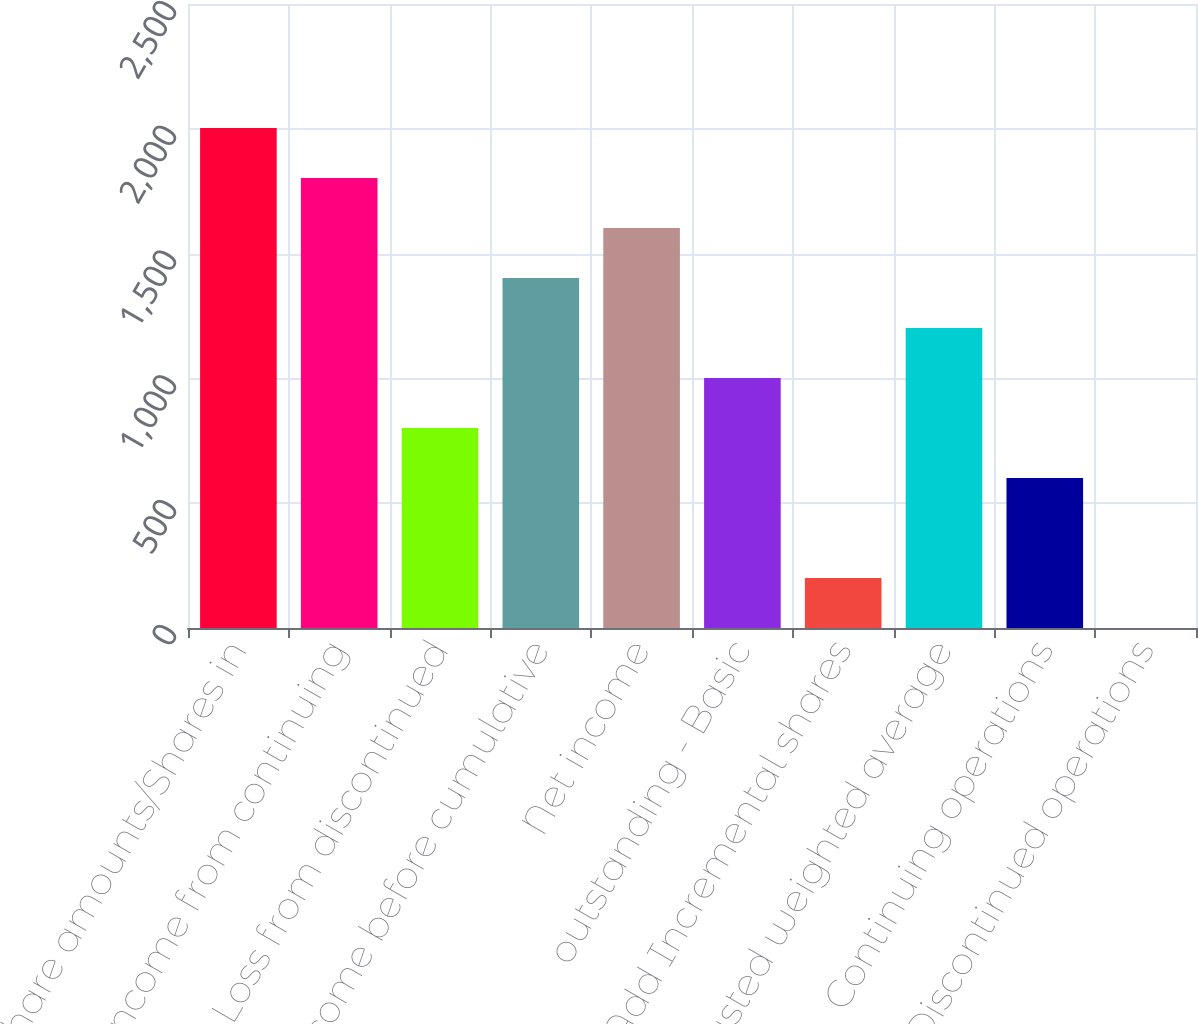Convert chart. <chart><loc_0><loc_0><loc_500><loc_500><bar_chart><fcel>share amounts/Shares in<fcel>Income from continuing<fcel>Loss from discontinued<fcel>Income before cumulative<fcel>Net income<fcel>outstanding - Basic<fcel>Add Incremental shares<fcel>Adjusted weighted average<fcel>Continuing operations<fcel>Discontinued operations<nl><fcel>2003<fcel>1802.75<fcel>801.5<fcel>1402.25<fcel>1602.5<fcel>1001.75<fcel>200.75<fcel>1202<fcel>601.25<fcel>0.5<nl></chart> 